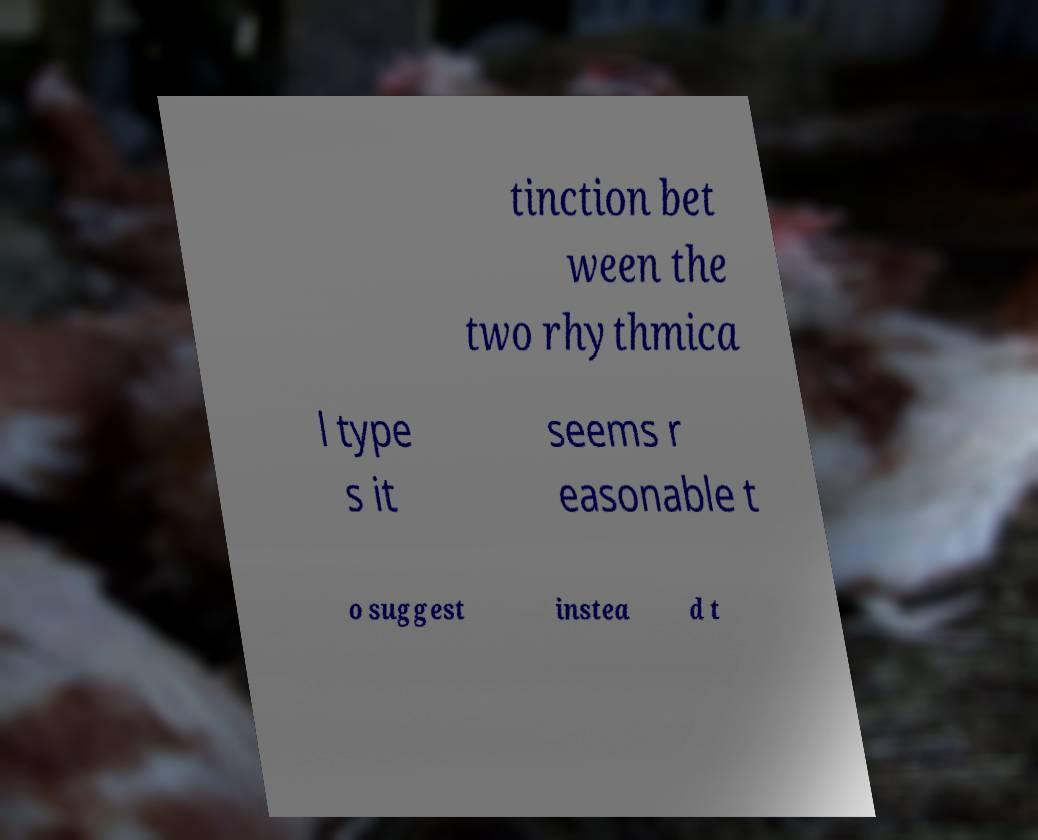Can you accurately transcribe the text from the provided image for me? tinction bet ween the two rhythmica l type s it seems r easonable t o suggest instea d t 